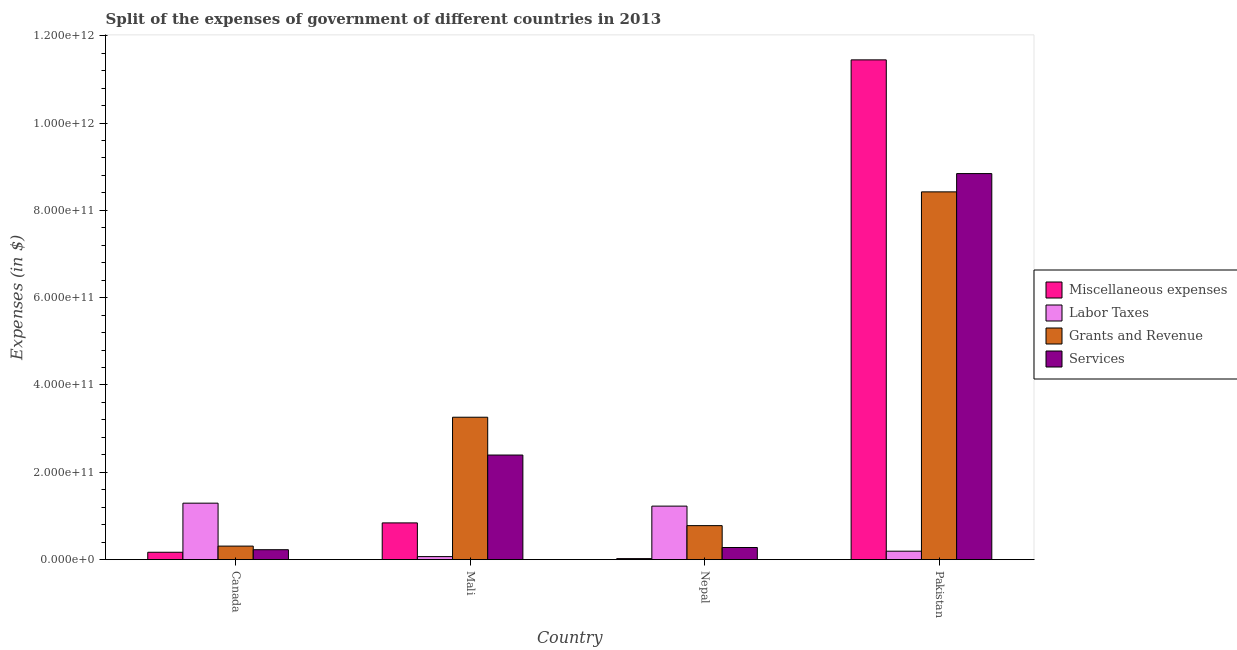How many groups of bars are there?
Provide a succinct answer. 4. How many bars are there on the 3rd tick from the left?
Your response must be concise. 4. How many bars are there on the 4th tick from the right?
Provide a short and direct response. 4. What is the amount spent on miscellaneous expenses in Canada?
Your answer should be very brief. 1.69e+1. Across all countries, what is the maximum amount spent on miscellaneous expenses?
Your response must be concise. 1.14e+12. Across all countries, what is the minimum amount spent on labor taxes?
Provide a short and direct response. 6.92e+09. In which country was the amount spent on miscellaneous expenses minimum?
Make the answer very short. Nepal. What is the total amount spent on services in the graph?
Offer a very short reply. 1.17e+12. What is the difference between the amount spent on grants and revenue in Mali and that in Pakistan?
Make the answer very short. -5.16e+11. What is the difference between the amount spent on labor taxes in Mali and the amount spent on miscellaneous expenses in Nepal?
Offer a terse response. 4.59e+09. What is the average amount spent on labor taxes per country?
Your answer should be compact. 6.95e+1. What is the difference between the amount spent on miscellaneous expenses and amount spent on services in Canada?
Ensure brevity in your answer.  -5.84e+09. What is the ratio of the amount spent on grants and revenue in Canada to that in Pakistan?
Make the answer very short. 0.04. Is the amount spent on labor taxes in Canada less than that in Pakistan?
Offer a very short reply. No. What is the difference between the highest and the second highest amount spent on services?
Keep it short and to the point. 6.45e+11. What is the difference between the highest and the lowest amount spent on labor taxes?
Give a very brief answer. 1.22e+11. In how many countries, is the amount spent on miscellaneous expenses greater than the average amount spent on miscellaneous expenses taken over all countries?
Offer a very short reply. 1. Is it the case that in every country, the sum of the amount spent on services and amount spent on grants and revenue is greater than the sum of amount spent on labor taxes and amount spent on miscellaneous expenses?
Make the answer very short. Yes. What does the 3rd bar from the left in Mali represents?
Offer a very short reply. Grants and Revenue. What does the 2nd bar from the right in Mali represents?
Make the answer very short. Grants and Revenue. Is it the case that in every country, the sum of the amount spent on miscellaneous expenses and amount spent on labor taxes is greater than the amount spent on grants and revenue?
Your answer should be compact. No. Are all the bars in the graph horizontal?
Offer a terse response. No. How many countries are there in the graph?
Your answer should be compact. 4. What is the difference between two consecutive major ticks on the Y-axis?
Your answer should be compact. 2.00e+11. Does the graph contain grids?
Make the answer very short. No. Where does the legend appear in the graph?
Offer a terse response. Center right. What is the title of the graph?
Make the answer very short. Split of the expenses of government of different countries in 2013. What is the label or title of the X-axis?
Provide a succinct answer. Country. What is the label or title of the Y-axis?
Provide a succinct answer. Expenses (in $). What is the Expenses (in $) in Miscellaneous expenses in Canada?
Keep it short and to the point. 1.69e+1. What is the Expenses (in $) in Labor Taxes in Canada?
Provide a short and direct response. 1.29e+11. What is the Expenses (in $) of Grants and Revenue in Canada?
Ensure brevity in your answer.  3.10e+1. What is the Expenses (in $) of Services in Canada?
Ensure brevity in your answer.  2.27e+1. What is the Expenses (in $) in Miscellaneous expenses in Mali?
Ensure brevity in your answer.  8.41e+1. What is the Expenses (in $) of Labor Taxes in Mali?
Make the answer very short. 6.92e+09. What is the Expenses (in $) of Grants and Revenue in Mali?
Your answer should be very brief. 3.26e+11. What is the Expenses (in $) in Services in Mali?
Make the answer very short. 2.40e+11. What is the Expenses (in $) of Miscellaneous expenses in Nepal?
Offer a very short reply. 2.33e+09. What is the Expenses (in $) in Labor Taxes in Nepal?
Keep it short and to the point. 1.23e+11. What is the Expenses (in $) of Grants and Revenue in Nepal?
Ensure brevity in your answer.  7.79e+1. What is the Expenses (in $) in Services in Nepal?
Make the answer very short. 2.78e+1. What is the Expenses (in $) of Miscellaneous expenses in Pakistan?
Make the answer very short. 1.14e+12. What is the Expenses (in $) of Labor Taxes in Pakistan?
Provide a succinct answer. 1.93e+1. What is the Expenses (in $) in Grants and Revenue in Pakistan?
Your answer should be very brief. 8.42e+11. What is the Expenses (in $) of Services in Pakistan?
Provide a succinct answer. 8.84e+11. Across all countries, what is the maximum Expenses (in $) in Miscellaneous expenses?
Provide a succinct answer. 1.14e+12. Across all countries, what is the maximum Expenses (in $) of Labor Taxes?
Offer a terse response. 1.29e+11. Across all countries, what is the maximum Expenses (in $) of Grants and Revenue?
Provide a succinct answer. 8.42e+11. Across all countries, what is the maximum Expenses (in $) of Services?
Give a very brief answer. 8.84e+11. Across all countries, what is the minimum Expenses (in $) of Miscellaneous expenses?
Ensure brevity in your answer.  2.33e+09. Across all countries, what is the minimum Expenses (in $) in Labor Taxes?
Ensure brevity in your answer.  6.92e+09. Across all countries, what is the minimum Expenses (in $) of Grants and Revenue?
Your answer should be very brief. 3.10e+1. Across all countries, what is the minimum Expenses (in $) in Services?
Offer a terse response. 2.27e+1. What is the total Expenses (in $) of Miscellaneous expenses in the graph?
Give a very brief answer. 1.25e+12. What is the total Expenses (in $) in Labor Taxes in the graph?
Offer a very short reply. 2.78e+11. What is the total Expenses (in $) of Grants and Revenue in the graph?
Ensure brevity in your answer.  1.28e+12. What is the total Expenses (in $) in Services in the graph?
Your response must be concise. 1.17e+12. What is the difference between the Expenses (in $) of Miscellaneous expenses in Canada and that in Mali?
Your answer should be very brief. -6.73e+1. What is the difference between the Expenses (in $) in Labor Taxes in Canada and that in Mali?
Your answer should be compact. 1.22e+11. What is the difference between the Expenses (in $) of Grants and Revenue in Canada and that in Mali?
Make the answer very short. -2.95e+11. What is the difference between the Expenses (in $) in Services in Canada and that in Mali?
Provide a short and direct response. -2.17e+11. What is the difference between the Expenses (in $) in Miscellaneous expenses in Canada and that in Nepal?
Offer a very short reply. 1.46e+1. What is the difference between the Expenses (in $) in Labor Taxes in Canada and that in Nepal?
Keep it short and to the point. 6.76e+09. What is the difference between the Expenses (in $) in Grants and Revenue in Canada and that in Nepal?
Keep it short and to the point. -4.69e+1. What is the difference between the Expenses (in $) of Services in Canada and that in Nepal?
Your answer should be very brief. -5.04e+09. What is the difference between the Expenses (in $) of Miscellaneous expenses in Canada and that in Pakistan?
Offer a very short reply. -1.13e+12. What is the difference between the Expenses (in $) in Labor Taxes in Canada and that in Pakistan?
Make the answer very short. 1.10e+11. What is the difference between the Expenses (in $) of Grants and Revenue in Canada and that in Pakistan?
Make the answer very short. -8.11e+11. What is the difference between the Expenses (in $) of Services in Canada and that in Pakistan?
Provide a succinct answer. -8.62e+11. What is the difference between the Expenses (in $) of Miscellaneous expenses in Mali and that in Nepal?
Provide a succinct answer. 8.18e+1. What is the difference between the Expenses (in $) in Labor Taxes in Mali and that in Nepal?
Provide a succinct answer. -1.16e+11. What is the difference between the Expenses (in $) of Grants and Revenue in Mali and that in Nepal?
Ensure brevity in your answer.  2.48e+11. What is the difference between the Expenses (in $) in Services in Mali and that in Nepal?
Make the answer very short. 2.12e+11. What is the difference between the Expenses (in $) in Miscellaneous expenses in Mali and that in Pakistan?
Keep it short and to the point. -1.06e+12. What is the difference between the Expenses (in $) in Labor Taxes in Mali and that in Pakistan?
Offer a terse response. -1.24e+1. What is the difference between the Expenses (in $) of Grants and Revenue in Mali and that in Pakistan?
Offer a very short reply. -5.16e+11. What is the difference between the Expenses (in $) in Services in Mali and that in Pakistan?
Your answer should be compact. -6.45e+11. What is the difference between the Expenses (in $) of Miscellaneous expenses in Nepal and that in Pakistan?
Make the answer very short. -1.14e+12. What is the difference between the Expenses (in $) in Labor Taxes in Nepal and that in Pakistan?
Give a very brief answer. 1.03e+11. What is the difference between the Expenses (in $) of Grants and Revenue in Nepal and that in Pakistan?
Ensure brevity in your answer.  -7.64e+11. What is the difference between the Expenses (in $) of Services in Nepal and that in Pakistan?
Offer a terse response. -8.56e+11. What is the difference between the Expenses (in $) of Miscellaneous expenses in Canada and the Expenses (in $) of Labor Taxes in Mali?
Your answer should be compact. 9.96e+09. What is the difference between the Expenses (in $) of Miscellaneous expenses in Canada and the Expenses (in $) of Grants and Revenue in Mali?
Your answer should be very brief. -3.09e+11. What is the difference between the Expenses (in $) in Miscellaneous expenses in Canada and the Expenses (in $) in Services in Mali?
Provide a short and direct response. -2.23e+11. What is the difference between the Expenses (in $) of Labor Taxes in Canada and the Expenses (in $) of Grants and Revenue in Mali?
Make the answer very short. -1.97e+11. What is the difference between the Expenses (in $) in Labor Taxes in Canada and the Expenses (in $) in Services in Mali?
Offer a terse response. -1.10e+11. What is the difference between the Expenses (in $) of Grants and Revenue in Canada and the Expenses (in $) of Services in Mali?
Offer a terse response. -2.09e+11. What is the difference between the Expenses (in $) of Miscellaneous expenses in Canada and the Expenses (in $) of Labor Taxes in Nepal?
Your answer should be compact. -1.06e+11. What is the difference between the Expenses (in $) in Miscellaneous expenses in Canada and the Expenses (in $) in Grants and Revenue in Nepal?
Your answer should be compact. -6.10e+1. What is the difference between the Expenses (in $) of Miscellaneous expenses in Canada and the Expenses (in $) of Services in Nepal?
Ensure brevity in your answer.  -1.09e+1. What is the difference between the Expenses (in $) in Labor Taxes in Canada and the Expenses (in $) in Grants and Revenue in Nepal?
Provide a short and direct response. 5.15e+1. What is the difference between the Expenses (in $) of Labor Taxes in Canada and the Expenses (in $) of Services in Nepal?
Make the answer very short. 1.02e+11. What is the difference between the Expenses (in $) of Grants and Revenue in Canada and the Expenses (in $) of Services in Nepal?
Provide a succinct answer. 3.23e+09. What is the difference between the Expenses (in $) of Miscellaneous expenses in Canada and the Expenses (in $) of Labor Taxes in Pakistan?
Give a very brief answer. -2.42e+09. What is the difference between the Expenses (in $) in Miscellaneous expenses in Canada and the Expenses (in $) in Grants and Revenue in Pakistan?
Give a very brief answer. -8.25e+11. What is the difference between the Expenses (in $) in Miscellaneous expenses in Canada and the Expenses (in $) in Services in Pakistan?
Your answer should be compact. -8.67e+11. What is the difference between the Expenses (in $) in Labor Taxes in Canada and the Expenses (in $) in Grants and Revenue in Pakistan?
Offer a very short reply. -7.13e+11. What is the difference between the Expenses (in $) in Labor Taxes in Canada and the Expenses (in $) in Services in Pakistan?
Your answer should be compact. -7.55e+11. What is the difference between the Expenses (in $) in Grants and Revenue in Canada and the Expenses (in $) in Services in Pakistan?
Your answer should be very brief. -8.53e+11. What is the difference between the Expenses (in $) in Miscellaneous expenses in Mali and the Expenses (in $) in Labor Taxes in Nepal?
Keep it short and to the point. -3.84e+1. What is the difference between the Expenses (in $) of Miscellaneous expenses in Mali and the Expenses (in $) of Grants and Revenue in Nepal?
Ensure brevity in your answer.  6.26e+09. What is the difference between the Expenses (in $) in Miscellaneous expenses in Mali and the Expenses (in $) in Services in Nepal?
Your response must be concise. 5.64e+1. What is the difference between the Expenses (in $) in Labor Taxes in Mali and the Expenses (in $) in Grants and Revenue in Nepal?
Ensure brevity in your answer.  -7.10e+1. What is the difference between the Expenses (in $) of Labor Taxes in Mali and the Expenses (in $) of Services in Nepal?
Your answer should be very brief. -2.08e+1. What is the difference between the Expenses (in $) in Grants and Revenue in Mali and the Expenses (in $) in Services in Nepal?
Provide a short and direct response. 2.98e+11. What is the difference between the Expenses (in $) of Miscellaneous expenses in Mali and the Expenses (in $) of Labor Taxes in Pakistan?
Give a very brief answer. 6.48e+1. What is the difference between the Expenses (in $) in Miscellaneous expenses in Mali and the Expenses (in $) in Grants and Revenue in Pakistan?
Your response must be concise. -7.58e+11. What is the difference between the Expenses (in $) in Miscellaneous expenses in Mali and the Expenses (in $) in Services in Pakistan?
Provide a short and direct response. -8.00e+11. What is the difference between the Expenses (in $) in Labor Taxes in Mali and the Expenses (in $) in Grants and Revenue in Pakistan?
Offer a very short reply. -8.35e+11. What is the difference between the Expenses (in $) of Labor Taxes in Mali and the Expenses (in $) of Services in Pakistan?
Offer a very short reply. -8.77e+11. What is the difference between the Expenses (in $) of Grants and Revenue in Mali and the Expenses (in $) of Services in Pakistan?
Keep it short and to the point. -5.58e+11. What is the difference between the Expenses (in $) in Miscellaneous expenses in Nepal and the Expenses (in $) in Labor Taxes in Pakistan?
Give a very brief answer. -1.70e+1. What is the difference between the Expenses (in $) of Miscellaneous expenses in Nepal and the Expenses (in $) of Grants and Revenue in Pakistan?
Your response must be concise. -8.40e+11. What is the difference between the Expenses (in $) of Miscellaneous expenses in Nepal and the Expenses (in $) of Services in Pakistan?
Offer a terse response. -8.82e+11. What is the difference between the Expenses (in $) of Labor Taxes in Nepal and the Expenses (in $) of Grants and Revenue in Pakistan?
Keep it short and to the point. -7.20e+11. What is the difference between the Expenses (in $) of Labor Taxes in Nepal and the Expenses (in $) of Services in Pakistan?
Give a very brief answer. -7.62e+11. What is the difference between the Expenses (in $) of Grants and Revenue in Nepal and the Expenses (in $) of Services in Pakistan?
Your answer should be compact. -8.06e+11. What is the average Expenses (in $) in Miscellaneous expenses per country?
Your answer should be very brief. 3.12e+11. What is the average Expenses (in $) in Labor Taxes per country?
Ensure brevity in your answer.  6.95e+1. What is the average Expenses (in $) in Grants and Revenue per country?
Offer a terse response. 3.19e+11. What is the average Expenses (in $) in Services per country?
Provide a succinct answer. 2.94e+11. What is the difference between the Expenses (in $) in Miscellaneous expenses and Expenses (in $) in Labor Taxes in Canada?
Provide a short and direct response. -1.12e+11. What is the difference between the Expenses (in $) in Miscellaneous expenses and Expenses (in $) in Grants and Revenue in Canada?
Offer a very short reply. -1.41e+1. What is the difference between the Expenses (in $) in Miscellaneous expenses and Expenses (in $) in Services in Canada?
Ensure brevity in your answer.  -5.84e+09. What is the difference between the Expenses (in $) in Labor Taxes and Expenses (in $) in Grants and Revenue in Canada?
Make the answer very short. 9.83e+1. What is the difference between the Expenses (in $) in Labor Taxes and Expenses (in $) in Services in Canada?
Your answer should be very brief. 1.07e+11. What is the difference between the Expenses (in $) of Grants and Revenue and Expenses (in $) of Services in Canada?
Ensure brevity in your answer.  8.27e+09. What is the difference between the Expenses (in $) of Miscellaneous expenses and Expenses (in $) of Labor Taxes in Mali?
Offer a terse response. 7.72e+1. What is the difference between the Expenses (in $) of Miscellaneous expenses and Expenses (in $) of Grants and Revenue in Mali?
Provide a succinct answer. -2.42e+11. What is the difference between the Expenses (in $) in Miscellaneous expenses and Expenses (in $) in Services in Mali?
Ensure brevity in your answer.  -1.55e+11. What is the difference between the Expenses (in $) in Labor Taxes and Expenses (in $) in Grants and Revenue in Mali?
Make the answer very short. -3.19e+11. What is the difference between the Expenses (in $) of Labor Taxes and Expenses (in $) of Services in Mali?
Give a very brief answer. -2.33e+11. What is the difference between the Expenses (in $) in Grants and Revenue and Expenses (in $) in Services in Mali?
Your response must be concise. 8.66e+1. What is the difference between the Expenses (in $) of Miscellaneous expenses and Expenses (in $) of Labor Taxes in Nepal?
Give a very brief answer. -1.20e+11. What is the difference between the Expenses (in $) in Miscellaneous expenses and Expenses (in $) in Grants and Revenue in Nepal?
Your response must be concise. -7.55e+1. What is the difference between the Expenses (in $) of Miscellaneous expenses and Expenses (in $) of Services in Nepal?
Make the answer very short. -2.54e+1. What is the difference between the Expenses (in $) in Labor Taxes and Expenses (in $) in Grants and Revenue in Nepal?
Provide a succinct answer. 4.47e+1. What is the difference between the Expenses (in $) in Labor Taxes and Expenses (in $) in Services in Nepal?
Your answer should be very brief. 9.48e+1. What is the difference between the Expenses (in $) in Grants and Revenue and Expenses (in $) in Services in Nepal?
Offer a very short reply. 5.01e+1. What is the difference between the Expenses (in $) of Miscellaneous expenses and Expenses (in $) of Labor Taxes in Pakistan?
Provide a short and direct response. 1.13e+12. What is the difference between the Expenses (in $) in Miscellaneous expenses and Expenses (in $) in Grants and Revenue in Pakistan?
Give a very brief answer. 3.02e+11. What is the difference between the Expenses (in $) of Miscellaneous expenses and Expenses (in $) of Services in Pakistan?
Your response must be concise. 2.60e+11. What is the difference between the Expenses (in $) in Labor Taxes and Expenses (in $) in Grants and Revenue in Pakistan?
Offer a very short reply. -8.23e+11. What is the difference between the Expenses (in $) in Labor Taxes and Expenses (in $) in Services in Pakistan?
Offer a terse response. -8.65e+11. What is the difference between the Expenses (in $) in Grants and Revenue and Expenses (in $) in Services in Pakistan?
Keep it short and to the point. -4.19e+1. What is the ratio of the Expenses (in $) in Miscellaneous expenses in Canada to that in Mali?
Offer a terse response. 0.2. What is the ratio of the Expenses (in $) in Labor Taxes in Canada to that in Mali?
Offer a very short reply. 18.68. What is the ratio of the Expenses (in $) in Grants and Revenue in Canada to that in Mali?
Offer a terse response. 0.1. What is the ratio of the Expenses (in $) in Services in Canada to that in Mali?
Your answer should be compact. 0.09. What is the ratio of the Expenses (in $) in Miscellaneous expenses in Canada to that in Nepal?
Keep it short and to the point. 7.24. What is the ratio of the Expenses (in $) of Labor Taxes in Canada to that in Nepal?
Give a very brief answer. 1.06. What is the ratio of the Expenses (in $) in Grants and Revenue in Canada to that in Nepal?
Give a very brief answer. 0.4. What is the ratio of the Expenses (in $) in Services in Canada to that in Nepal?
Ensure brevity in your answer.  0.82. What is the ratio of the Expenses (in $) in Miscellaneous expenses in Canada to that in Pakistan?
Give a very brief answer. 0.01. What is the ratio of the Expenses (in $) in Labor Taxes in Canada to that in Pakistan?
Provide a short and direct response. 6.7. What is the ratio of the Expenses (in $) in Grants and Revenue in Canada to that in Pakistan?
Make the answer very short. 0.04. What is the ratio of the Expenses (in $) in Services in Canada to that in Pakistan?
Provide a succinct answer. 0.03. What is the ratio of the Expenses (in $) in Miscellaneous expenses in Mali to that in Nepal?
Your response must be concise. 36.06. What is the ratio of the Expenses (in $) in Labor Taxes in Mali to that in Nepal?
Give a very brief answer. 0.06. What is the ratio of the Expenses (in $) in Grants and Revenue in Mali to that in Nepal?
Offer a very short reply. 4.19. What is the ratio of the Expenses (in $) of Services in Mali to that in Nepal?
Make the answer very short. 8.63. What is the ratio of the Expenses (in $) of Miscellaneous expenses in Mali to that in Pakistan?
Offer a very short reply. 0.07. What is the ratio of the Expenses (in $) of Labor Taxes in Mali to that in Pakistan?
Provide a succinct answer. 0.36. What is the ratio of the Expenses (in $) in Grants and Revenue in Mali to that in Pakistan?
Provide a succinct answer. 0.39. What is the ratio of the Expenses (in $) of Services in Mali to that in Pakistan?
Ensure brevity in your answer.  0.27. What is the ratio of the Expenses (in $) in Miscellaneous expenses in Nepal to that in Pakistan?
Your answer should be very brief. 0. What is the ratio of the Expenses (in $) of Labor Taxes in Nepal to that in Pakistan?
Provide a succinct answer. 6.35. What is the ratio of the Expenses (in $) of Grants and Revenue in Nepal to that in Pakistan?
Your answer should be compact. 0.09. What is the ratio of the Expenses (in $) of Services in Nepal to that in Pakistan?
Offer a terse response. 0.03. What is the difference between the highest and the second highest Expenses (in $) in Miscellaneous expenses?
Your answer should be compact. 1.06e+12. What is the difference between the highest and the second highest Expenses (in $) of Labor Taxes?
Make the answer very short. 6.76e+09. What is the difference between the highest and the second highest Expenses (in $) of Grants and Revenue?
Your response must be concise. 5.16e+11. What is the difference between the highest and the second highest Expenses (in $) in Services?
Ensure brevity in your answer.  6.45e+11. What is the difference between the highest and the lowest Expenses (in $) in Miscellaneous expenses?
Your answer should be compact. 1.14e+12. What is the difference between the highest and the lowest Expenses (in $) of Labor Taxes?
Keep it short and to the point. 1.22e+11. What is the difference between the highest and the lowest Expenses (in $) of Grants and Revenue?
Your response must be concise. 8.11e+11. What is the difference between the highest and the lowest Expenses (in $) of Services?
Provide a short and direct response. 8.62e+11. 